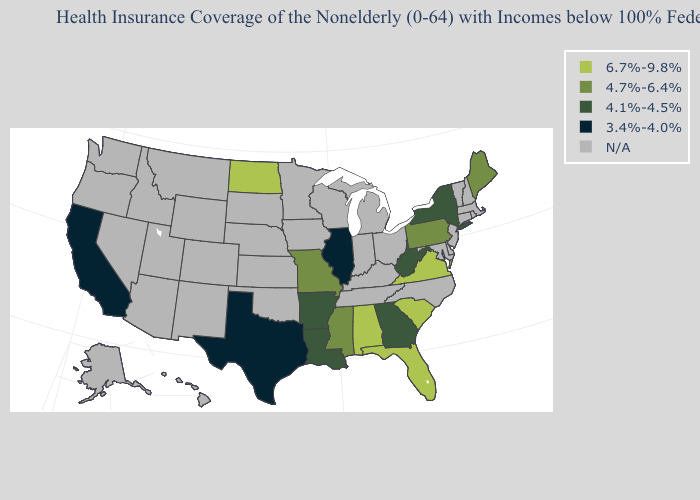Name the states that have a value in the range 3.4%-4.0%?
Quick response, please. California, Illinois, Texas. Name the states that have a value in the range 6.7%-9.8%?
Keep it brief. Alabama, Florida, North Dakota, South Carolina, Virginia. Name the states that have a value in the range 4.1%-4.5%?
Answer briefly. Arkansas, Georgia, Louisiana, New York, West Virginia. How many symbols are there in the legend?
Give a very brief answer. 5. Which states have the lowest value in the MidWest?
Quick response, please. Illinois. Name the states that have a value in the range 6.7%-9.8%?
Concise answer only. Alabama, Florida, North Dakota, South Carolina, Virginia. Among the states that border Mississippi , which have the lowest value?
Keep it brief. Arkansas, Louisiana. Name the states that have a value in the range 4.1%-4.5%?
Short answer required. Arkansas, Georgia, Louisiana, New York, West Virginia. Does the first symbol in the legend represent the smallest category?
Concise answer only. No. Which states have the highest value in the USA?
Write a very short answer. Alabama, Florida, North Dakota, South Carolina, Virginia. What is the highest value in the MidWest ?
Concise answer only. 6.7%-9.8%. How many symbols are there in the legend?
Short answer required. 5. How many symbols are there in the legend?
Write a very short answer. 5. Name the states that have a value in the range 3.4%-4.0%?
Write a very short answer. California, Illinois, Texas. 